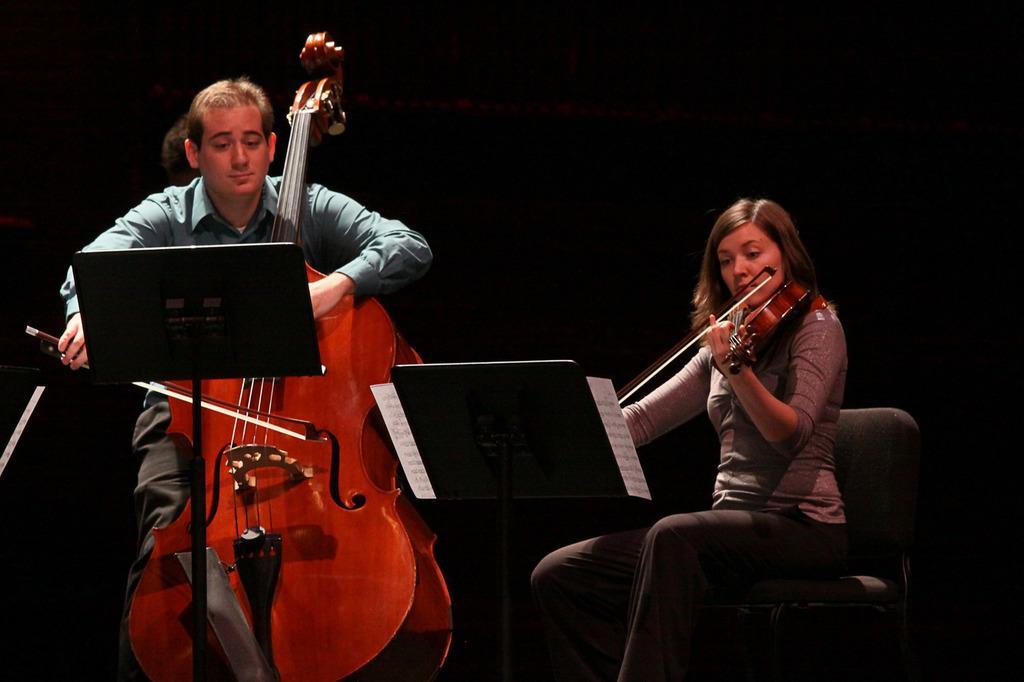Please provide a concise description of this image. In this picture a man and woman are holding and playing the violin 